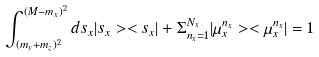<formula> <loc_0><loc_0><loc_500><loc_500>\int _ { ( m _ { y } + m _ { z } ) ^ { 2 } } ^ { ( M - m _ { x } ) ^ { 2 } } d s _ { x } | s _ { x } > < s _ { x } | + \Sigma _ { n _ { x } = 1 } ^ { N _ { x } } | \mu _ { x } ^ { n _ { x } } > < \mu _ { x } ^ { n _ { x } } | = { 1 }</formula> 